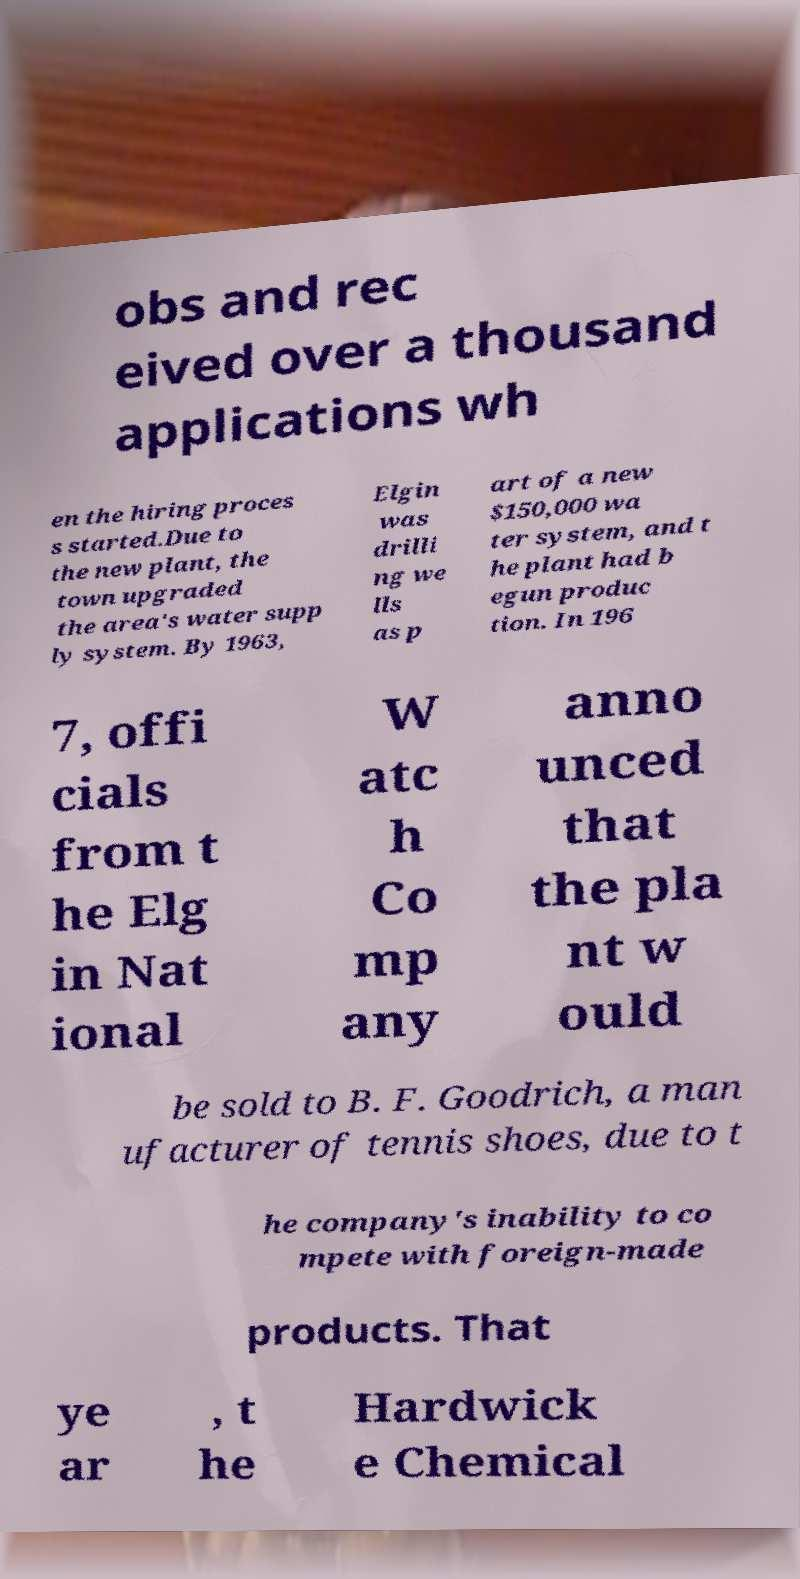What messages or text are displayed in this image? I need them in a readable, typed format. obs and rec eived over a thousand applications wh en the hiring proces s started.Due to the new plant, the town upgraded the area's water supp ly system. By 1963, Elgin was drilli ng we lls as p art of a new $150,000 wa ter system, and t he plant had b egun produc tion. In 196 7, offi cials from t he Elg in Nat ional W atc h Co mp any anno unced that the pla nt w ould be sold to B. F. Goodrich, a man ufacturer of tennis shoes, due to t he company's inability to co mpete with foreign-made products. That ye ar , t he Hardwick e Chemical 